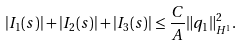Convert formula to latex. <formula><loc_0><loc_0><loc_500><loc_500>| I _ { 1 } ( s ) | + | I _ { 2 } ( s ) | + | I _ { 3 } ( s ) | \leq \frac { C } { A } \| q _ { 1 } \| _ { H ^ { 1 } } ^ { 2 } .</formula> 